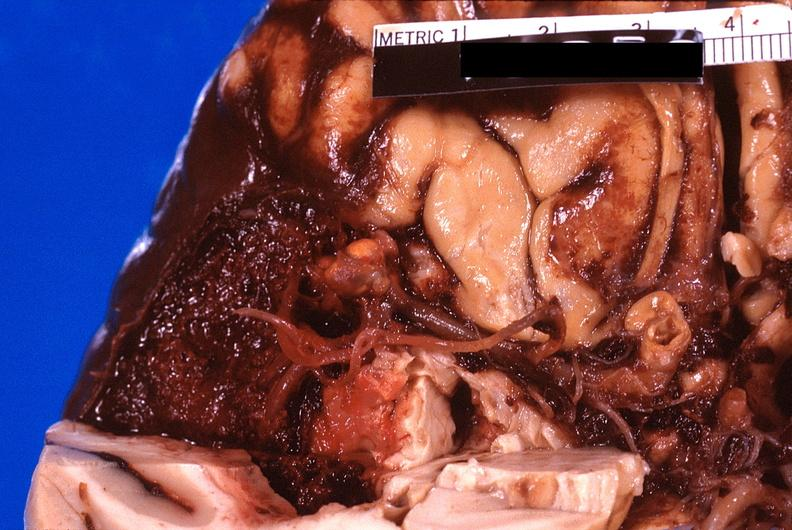what is present?
Answer the question using a single word or phrase. Nervous 